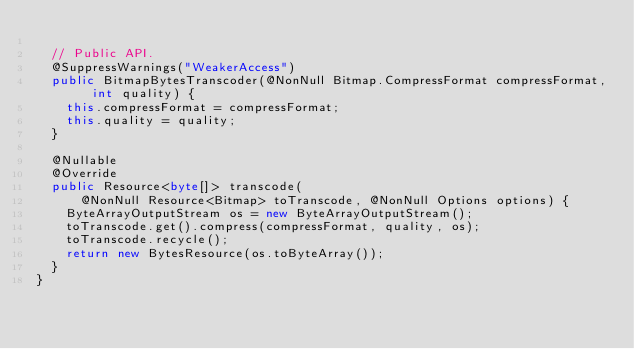<code> <loc_0><loc_0><loc_500><loc_500><_Java_>
  // Public API.
  @SuppressWarnings("WeakerAccess")
  public BitmapBytesTranscoder(@NonNull Bitmap.CompressFormat compressFormat, int quality) {
    this.compressFormat = compressFormat;
    this.quality = quality;
  }

  @Nullable
  @Override
  public Resource<byte[]> transcode(
      @NonNull Resource<Bitmap> toTranscode, @NonNull Options options) {
    ByteArrayOutputStream os = new ByteArrayOutputStream();
    toTranscode.get().compress(compressFormat, quality, os);
    toTranscode.recycle();
    return new BytesResource(os.toByteArray());
  }
}
</code> 